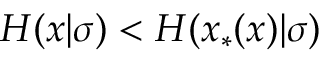Convert formula to latex. <formula><loc_0><loc_0><loc_500><loc_500>H ( x | \sigma ) < H ( x _ { * } ( x ) | \sigma )</formula> 